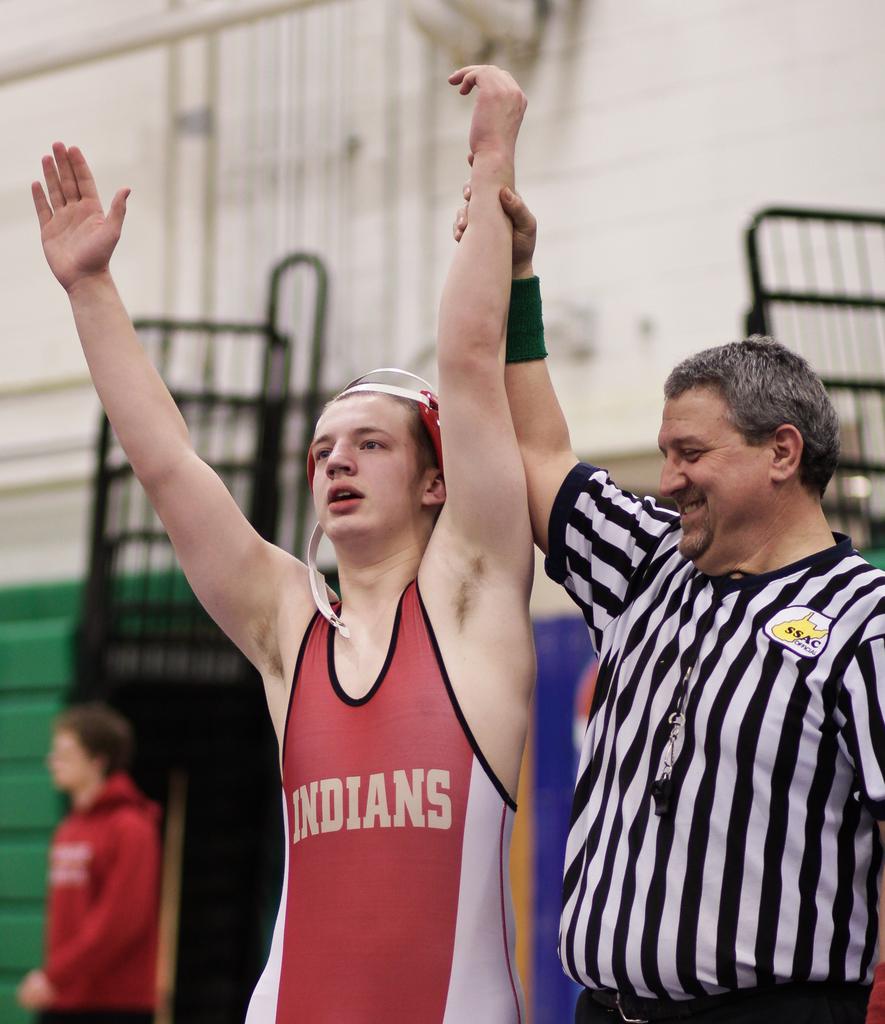What abbreviation is on the refs shirt?
Give a very brief answer. Ssac. 